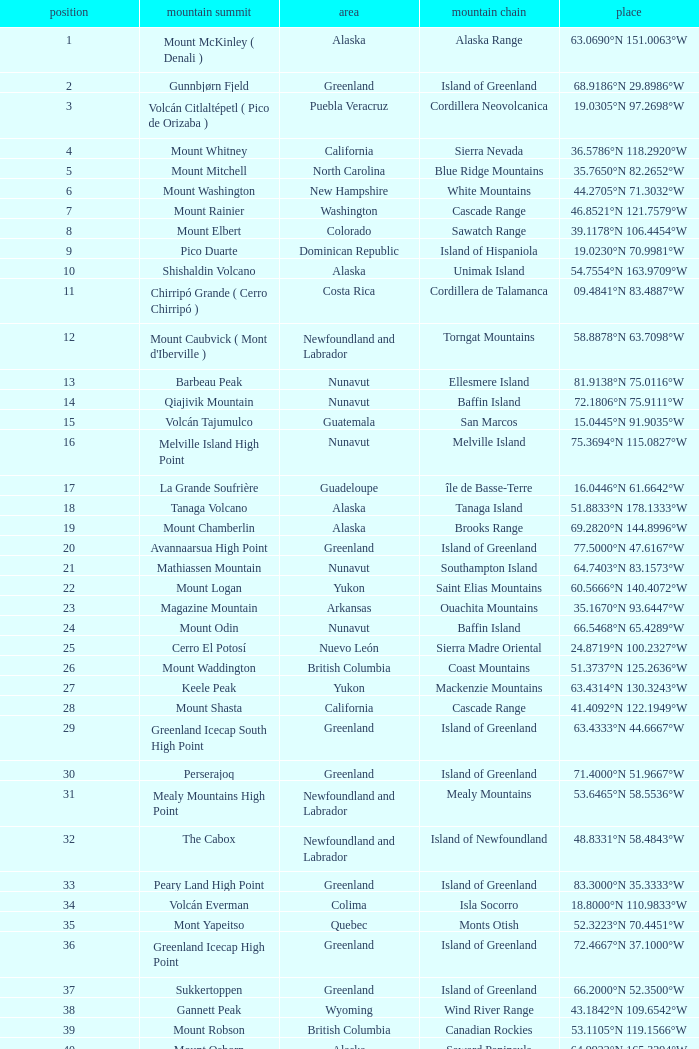Which Mountain Range has a Region of haiti, and a Location of 18.3601°n 71.9764°w? Island of Hispaniola. 